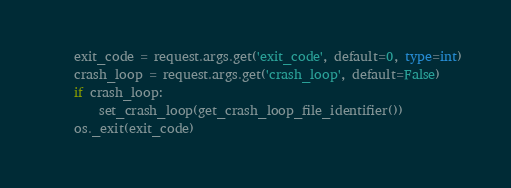<code> <loc_0><loc_0><loc_500><loc_500><_Python_>    exit_code = request.args.get('exit_code', default=0, type=int)
    crash_loop = request.args.get('crash_loop', default=False)
    if crash_loop:
        set_crash_loop(get_crash_loop_file_identifier())
    os._exit(exit_code)
</code> 